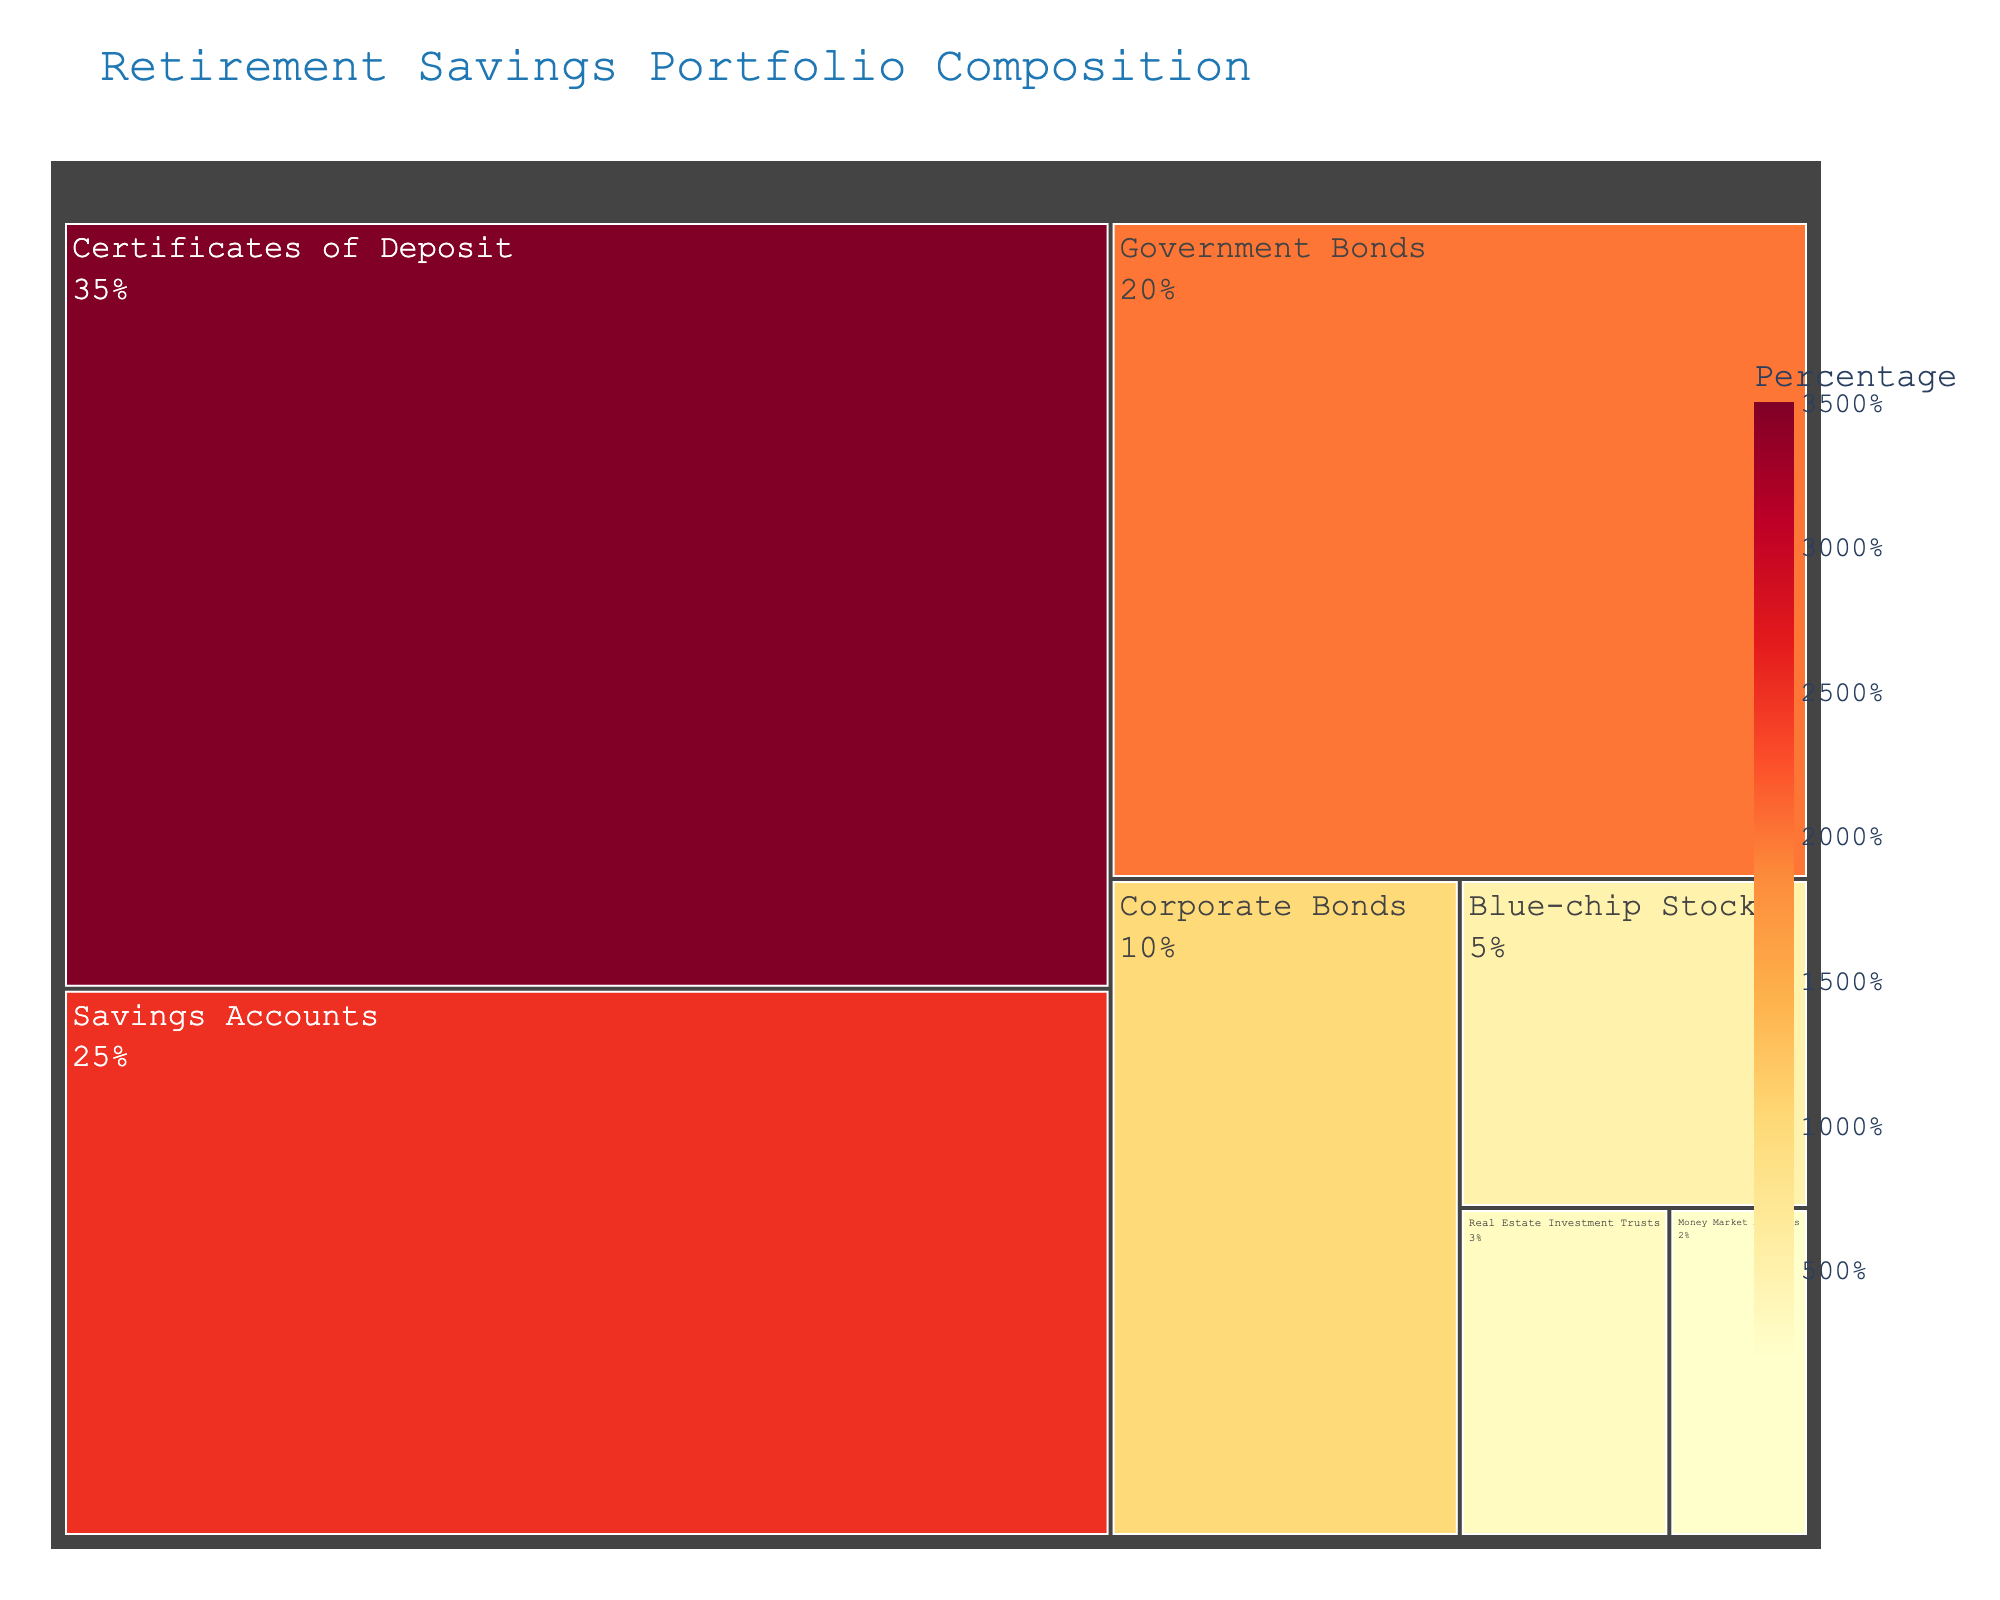what is the highest percentage investment type shown in the treemap? The treemap shows the percentage composition of various investment types. The largest segment, which is clearly labeled, indicates the highest percentage.
Answer: Certificates of Deposit What is the combined percentage of Government Bonds and Corporate Bonds? Locate the segments for both Government Bonds and Corporate Bonds in the treemap. Sum their percentages: 20% + 10% = 30%.
Answer: 30% What types of investments are shown in the smallest segments? The smallest segments in the treemap are lightly colored and located at the corners or edges and labeled with their names and percentages. They are Money Market Accounts and Real Estate Investment Trusts.
Answer: Money Market Accounts and Real Estate Investment Trusts Which two investment types have the second and third highest percentages in the portfolio? The treemap displays all investment types along with their percentages. The second highest after Certificates of Deposit (35%) is Savings Accounts (25%) and the third highest is Government Bonds (20%).
Answer: Savings Accounts and Government Bonds How much larger is the percentage of Savings Accounts compared to Blue-chip Stocks? Determine the percentages from the treemap: Savings Accounts is 25% and Blue-chip Stocks is 5%. Subtract the smaller value from the larger value: 25% - 5% = 20%.
Answer: 20% What percentage of the portfolio is made up of Real Estate Investment Trusts and Money Market Accounts together? Locate the segments for Real Estate Investment Trusts and Money Market Accounts in the treemap. Sum their percentages: 3% + 2% = 5%.
Answer: 5% Which investment type has a higher percentage: Government Bonds or Corporate Bonds? Compare the segments labeled Government Bonds and Corporate Bonds in the treemap. Government Bonds is 20% and Corporate Bonds is 10%, so Government Bonds is higher.
Answer: Government Bonds How does the percentage of Corporate Bonds compare to that of Blue-chip Stocks and Real Estate Investment Trusts combined? Corporate Bonds is 10%. Blue-chip Stocks and Real Estate Investment Trusts combined is 5% + 3% = 8%. So, Corporate Bonds is 2% higher than the combined value.
Answer: Corporate Bonds is 2% higher What is the total percentage of all investments represented in the portfolio? Sum the percentages of all investment types displayed in the treemap: 35% + 25% + 20% + 10% + 5% + 3% + 2% = 100%.
Answer: 100% Based on the color scheme, which investment type has a value closest to the middle range? The color scheme ranges from yellow to red, indicating lower to higher value. The middle range should be around 15%-25%. Savings Accounts at 25% appears to be in the middle of this color range.
Answer: Savings Accounts 